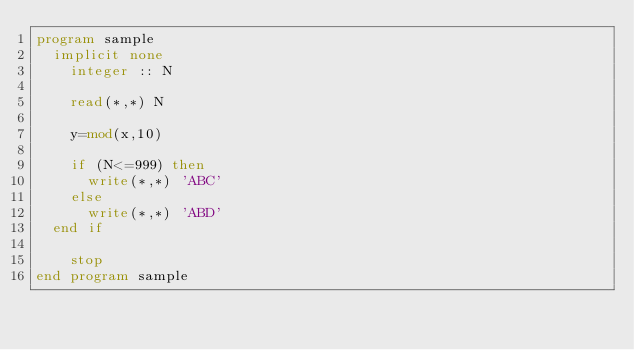Convert code to text. <code><loc_0><loc_0><loc_500><loc_500><_FORTRAN_>program sample
	implicit none
    integer :: N
    
    read(*,*) N
    
    y=mod(x,10)
    
    if (N<=999) then
    	write(*,*) 'ABC'
    else
    	write(*,*) 'ABD'
	end if

    stop
end program sample
</code> 